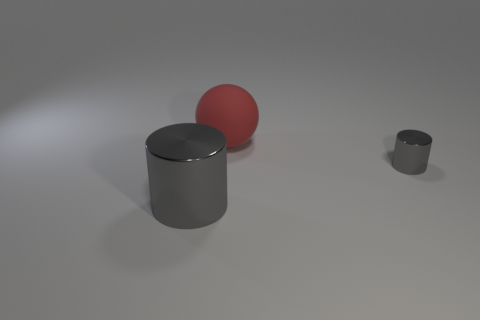Add 3 gray metallic cylinders. How many objects exist? 6 Subtract all cylinders. How many objects are left? 1 Subtract 0 yellow cubes. How many objects are left? 3 Subtract all large gray metallic objects. Subtract all big metal things. How many objects are left? 1 Add 3 big red objects. How many big red objects are left? 4 Add 2 big red objects. How many big red objects exist? 3 